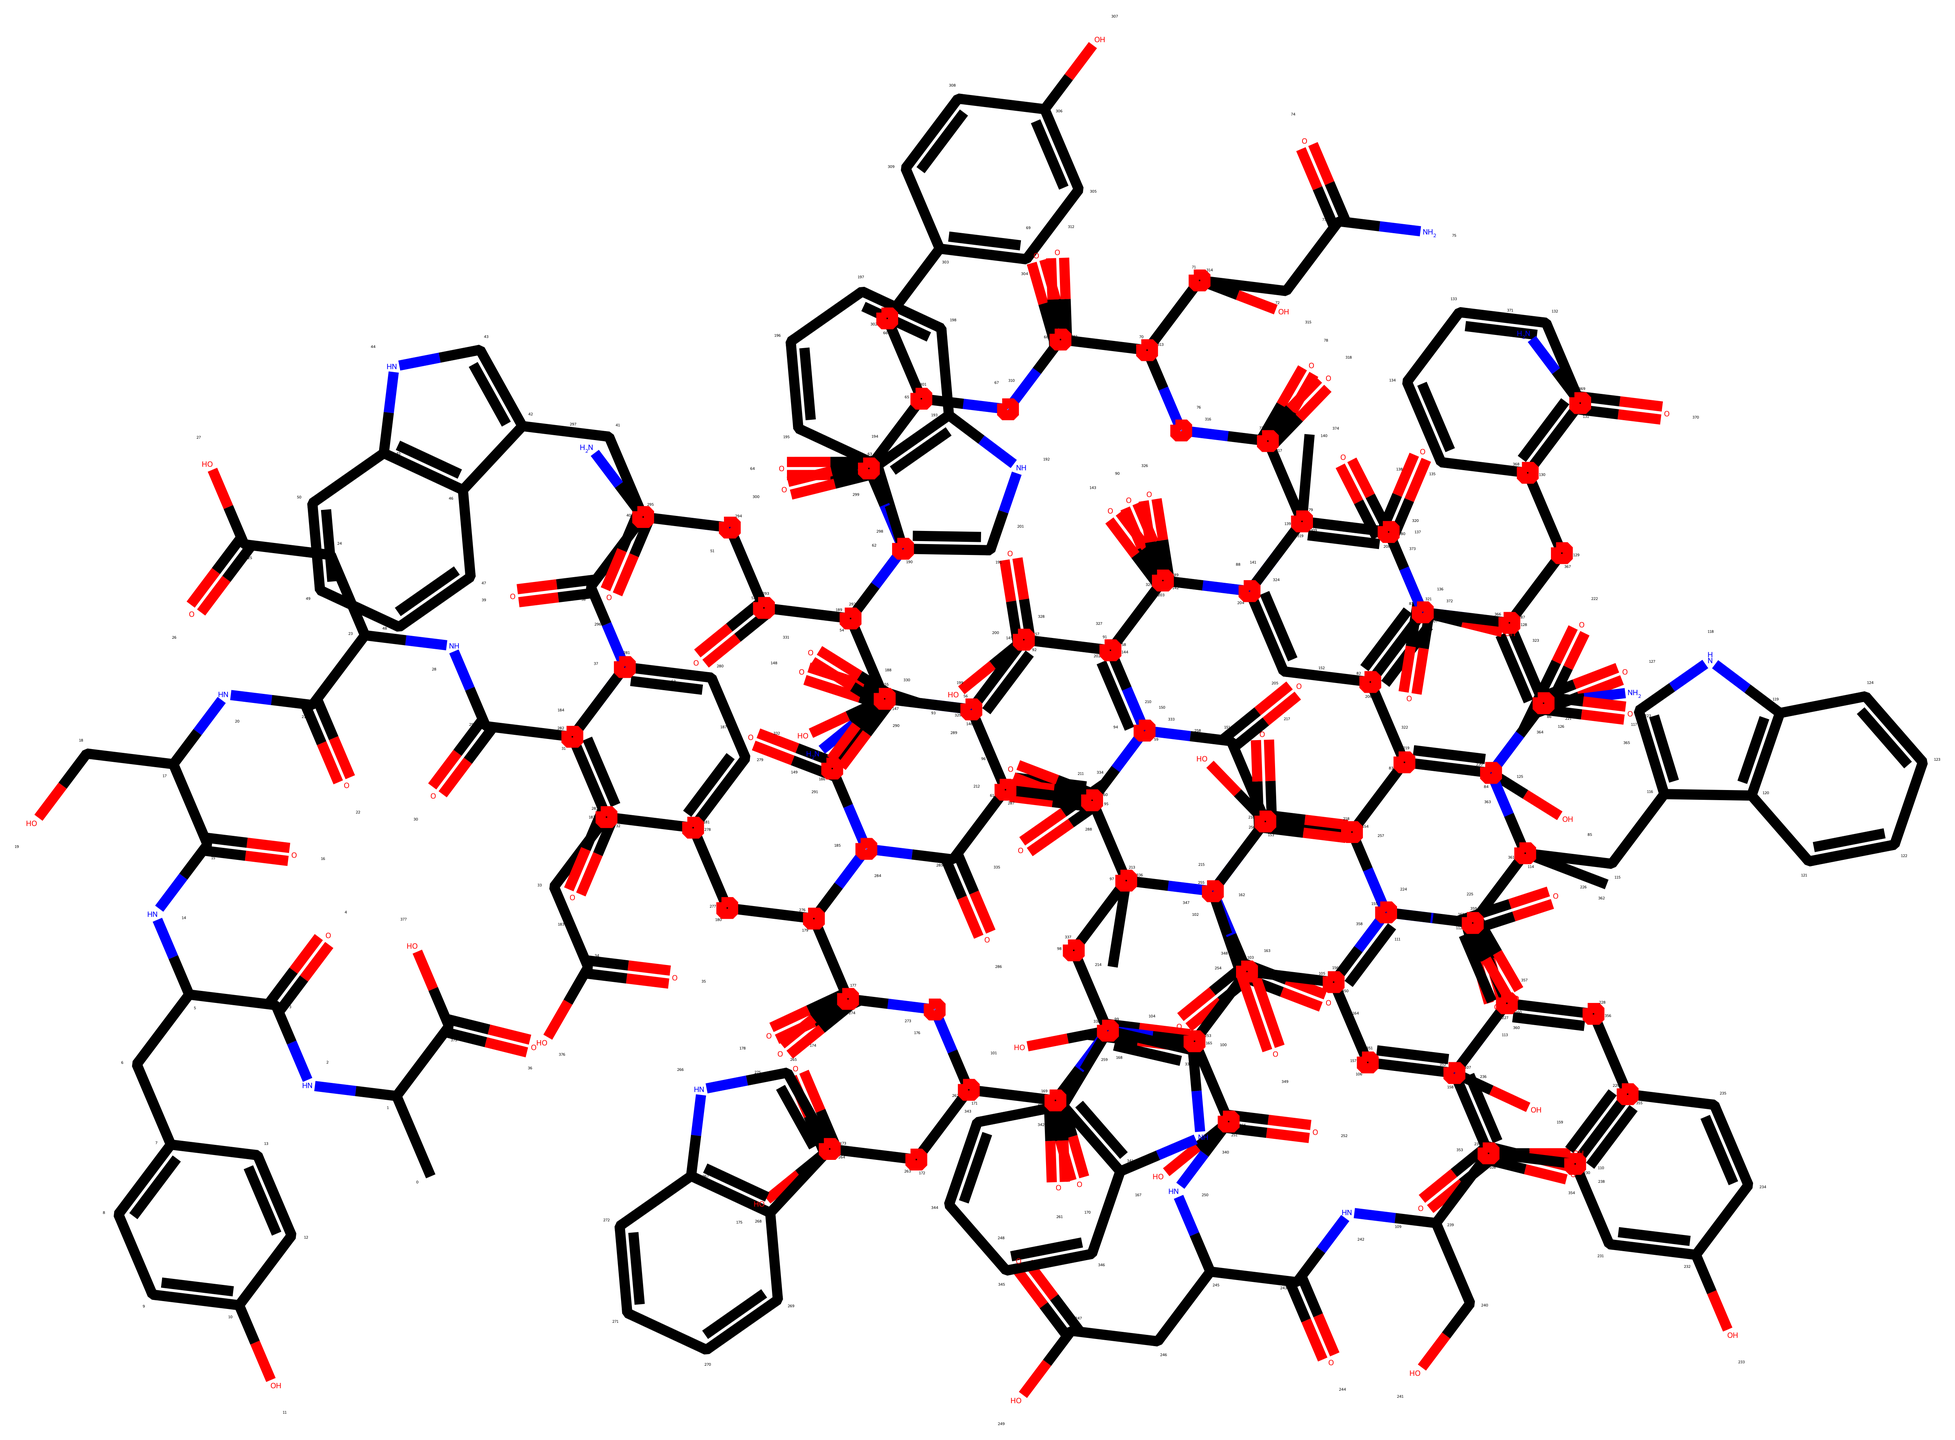What is the main protein component of silk fibers? The primary protein in silk fibers is fibroin, which is evident from the name that is also linked to the structure represented in the SMILES string.
Answer: fibroin How many oxygen atoms are present in the structure? By carefully analyzing the SMILES representation, we identify all the occurrences of the letter "O," which indicates oxygen. Counting them reveals a total of 16 oxygen atoms.
Answer: 16 What type of bonds are present within the main structure? The various nitrogen (N) and carbon (C) segments in the SMILES suggest amide bonds (from NC(=O)), typical in peptide structures. Therefore, the primary bonds are amide bonds.
Answer: amide How many amino acid units are likely represented in the silk fibroin structure? Given the complexity of the SMILES structure and the repeated NC(=O) sequences, this is indicative of multiple amino acid units. Upon careful examination, it's estimated that there are approximately 20 units, reflecting the sequence length.
Answer: 20 Which functional groups can be observed in this chemical structure? The presence of hydroxyl (-OH), carbonyl (C=O), and amine (-NH) groups can be identified through the characterization of bonds in the structure based on the SMILES. Thus, it contains these functional groups.
Answer: hydroxyl, carbonyl, amine What can be inferred about the hydrophilic characteristics of this molecule? The presence of multiple -OH groups indicates a high capacity for hydrogen bonding, which suggests that these parts of the molecule contribute to its hydrophilic nature. Overall, the structure shows hydrophilic properties.
Answer: hydrophilic 